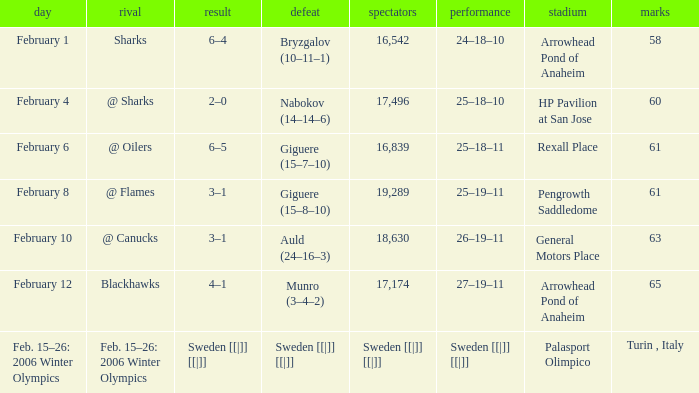What were the points on February 10? 63.0. 